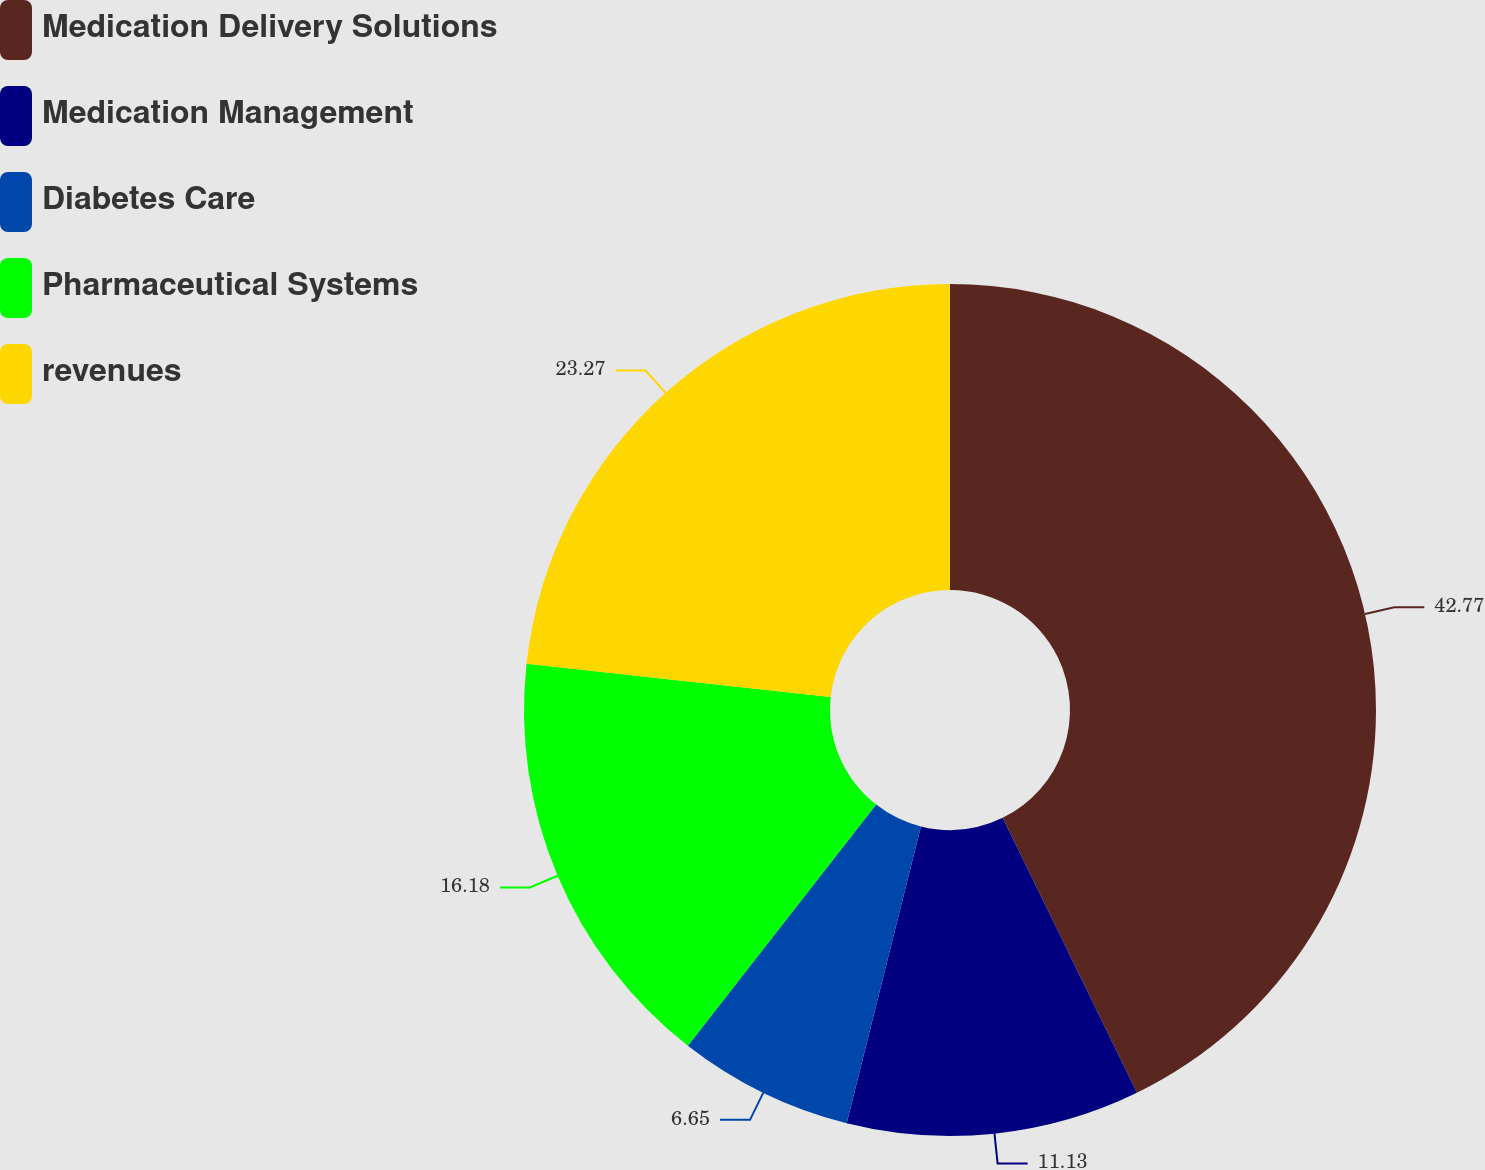<chart> <loc_0><loc_0><loc_500><loc_500><pie_chart><fcel>Medication Delivery Solutions<fcel>Medication Management<fcel>Diabetes Care<fcel>Pharmaceutical Systems<fcel>revenues<nl><fcel>42.77%<fcel>11.13%<fcel>6.65%<fcel>16.18%<fcel>23.27%<nl></chart> 